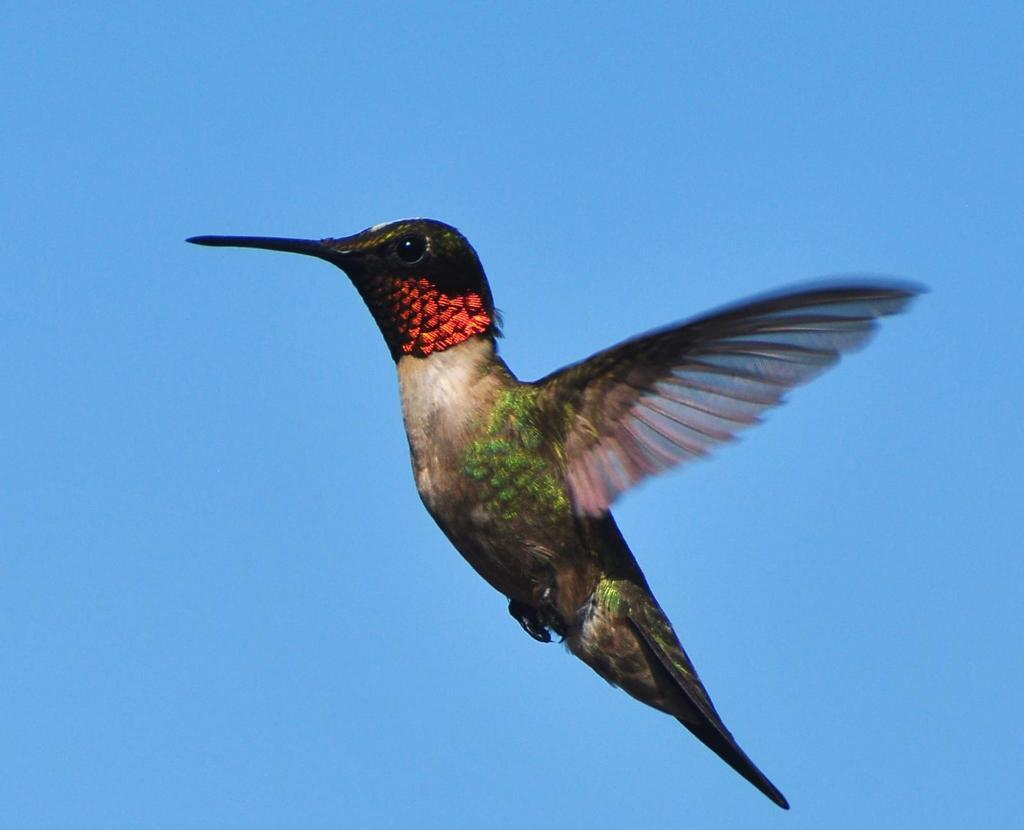What type of bird is in the image? There is a hummingbird in the image. What is the hummingbird doing in the image? The hummingbird is flying in the image. What can be seen in the background of the image? The sky is visible in the background of the image. How many mint leaves are on the sheet in the image? There is no sheet or mint leaves present in the image; it features a hummingbird flying in the sky. 